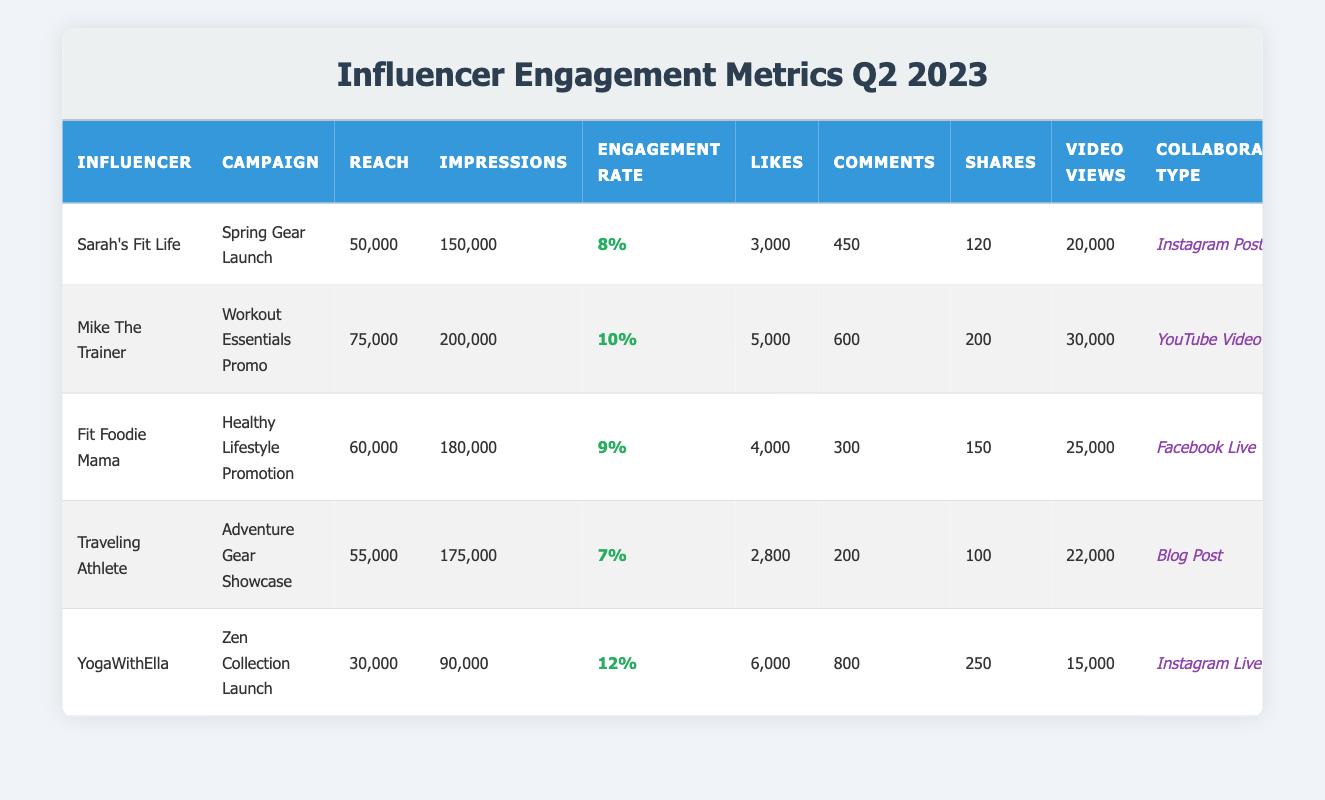What is the engagement rate of Mike The Trainer's campaign? Mike The Trainer's engagement rate is listed in the table under the column "Engagement Rate," which is 10%.
Answer: 10% Which influencer had the highest number of likes? The table shows that YogaWithElla received 6,000 likes, which is the highest among all influencers in the data.
Answer: YogaWithElla Is the reach of Fit Foodie Mama greater than that of Sarah's Fit Life? Fit Foodie Mama's reach is 60,000, while Sarah's Fit Life has a reach of 50,000. Since 60,000 is greater than 50,000, the answer is yes.
Answer: Yes What is the total number of comments across all campaigns? To find the total, we add the comments from all influencers: 450 + 600 + 300 + 200 + 800 = 2350.
Answer: 2350 What is the average engagement rate of the influencers listed in the table? The engagement rates are 8%, 10%, 9%, 7%, and 12%. We calculate the sum of these rates: 8 + 10 + 9 + 7 + 12 = 56. Then, we divide by the number of influencers, which is 5: 56/5 = 11.2.
Answer: 11.2 Does the collaboration type for Traveling Athlete involve video content? Traveling Athlete's collaboration type is listed as "Blog Post," which does not involve video. Therefore, the answer is no.
Answer: No Which campaign had the lowest engagement rate and what was that rate? Looking through the engagement rates, Traveling Athlete's campaign has the lowest rate at 7%.
Answer: 7% How many total video views were recorded for the campaign "Zen Collection Launch"? The number of video views for the "Zen Collection Launch" campaign by YogaWithElla is reported as 15,000.
Answer: 15,000 Which influencer had the highest reach and what was that reach? Mike The Trainer has the highest reach listed at 75,000.
Answer: 75,000 